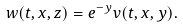<formula> <loc_0><loc_0><loc_500><loc_500>w ( t , x , z ) = e ^ { - y } v ( t , x , y ) .</formula> 